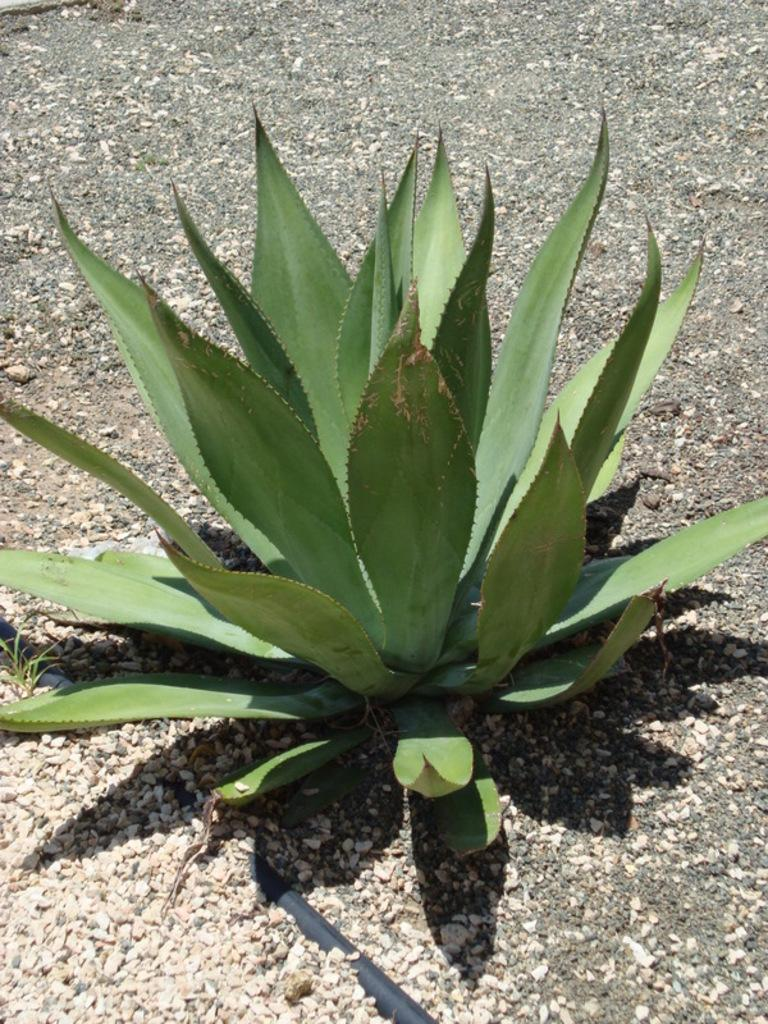What type of living organism can be seen in the image? There is a plant in the image. What can be found on the ground in the image? There are stones on the ground in the image. What type of sheet is covering the sofa in the image? There is no sofa or sheet present in the image; it only features a plant and stones on the ground. 